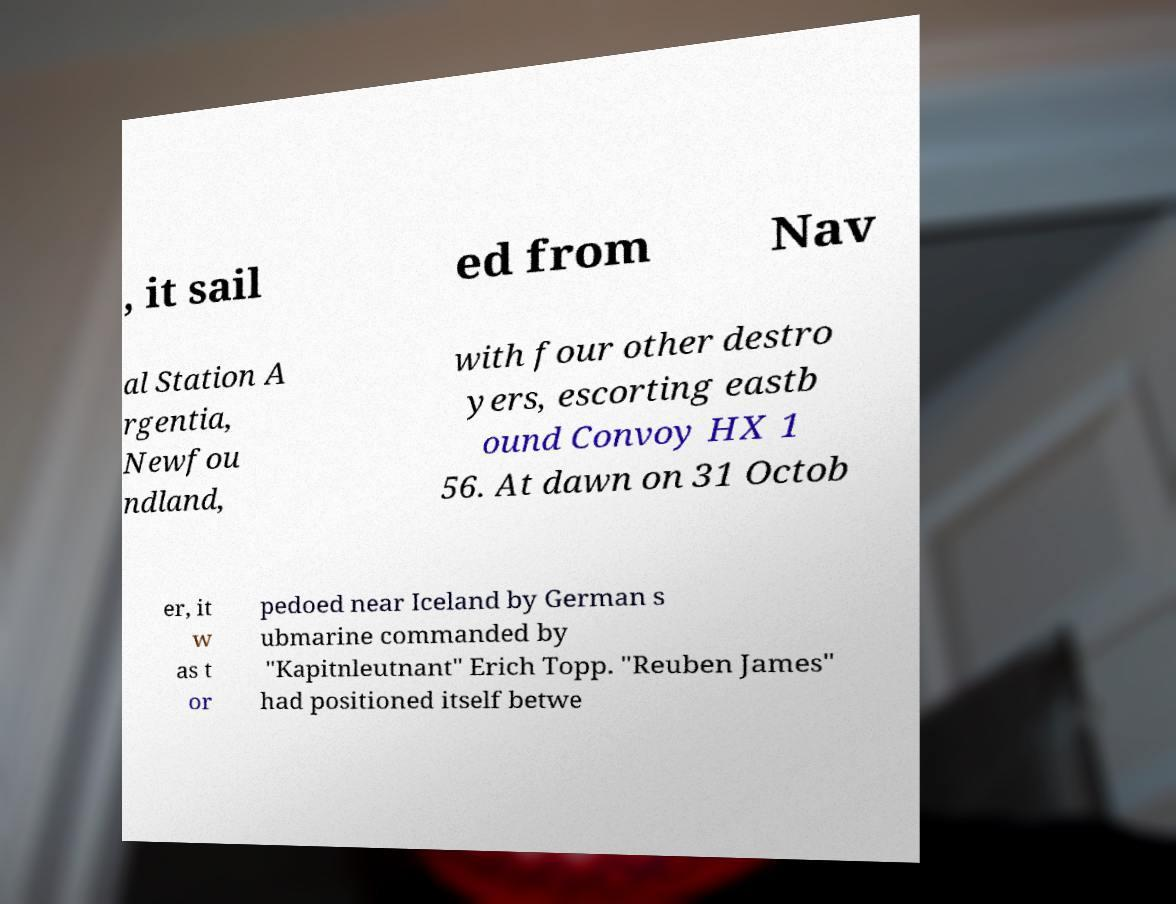What messages or text are displayed in this image? I need them in a readable, typed format. , it sail ed from Nav al Station A rgentia, Newfou ndland, with four other destro yers, escorting eastb ound Convoy HX 1 56. At dawn on 31 Octob er, it w as t or pedoed near Iceland by German s ubmarine commanded by "Kapitnleutnant" Erich Topp. "Reuben James" had positioned itself betwe 